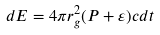<formula> <loc_0><loc_0><loc_500><loc_500>d E = 4 \pi r _ { g } ^ { 2 } ( P + \varepsilon ) c d t</formula> 